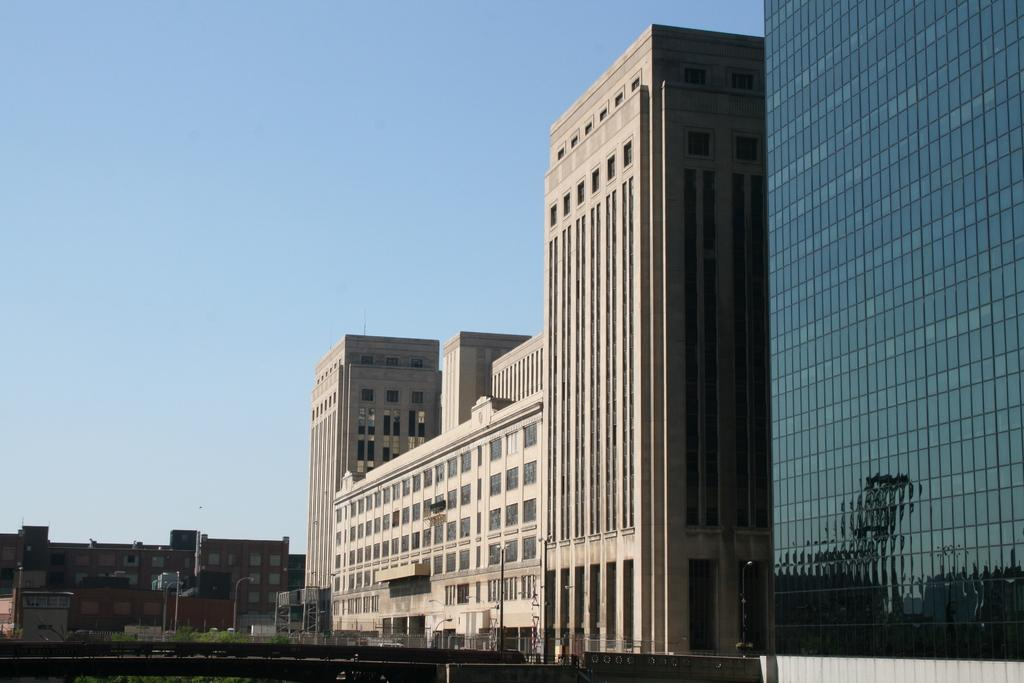What structures are visible in the image? There are buildings in the image. Where are the poles located in the image? The poles are on the left side of the image. What can be seen in the background of the image? The sky is visible in the background of the image. How does the cow interact with the buildings in the image? There is no cow present in the image, so it cannot interact with the buildings. 